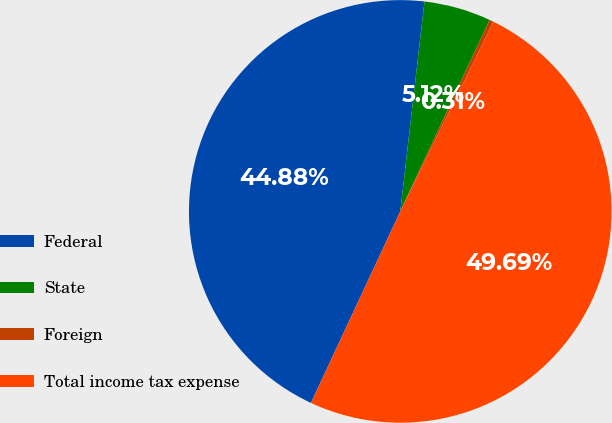<chart> <loc_0><loc_0><loc_500><loc_500><pie_chart><fcel>Federal<fcel>State<fcel>Foreign<fcel>Total income tax expense<nl><fcel>44.88%<fcel>5.12%<fcel>0.31%<fcel>49.69%<nl></chart> 